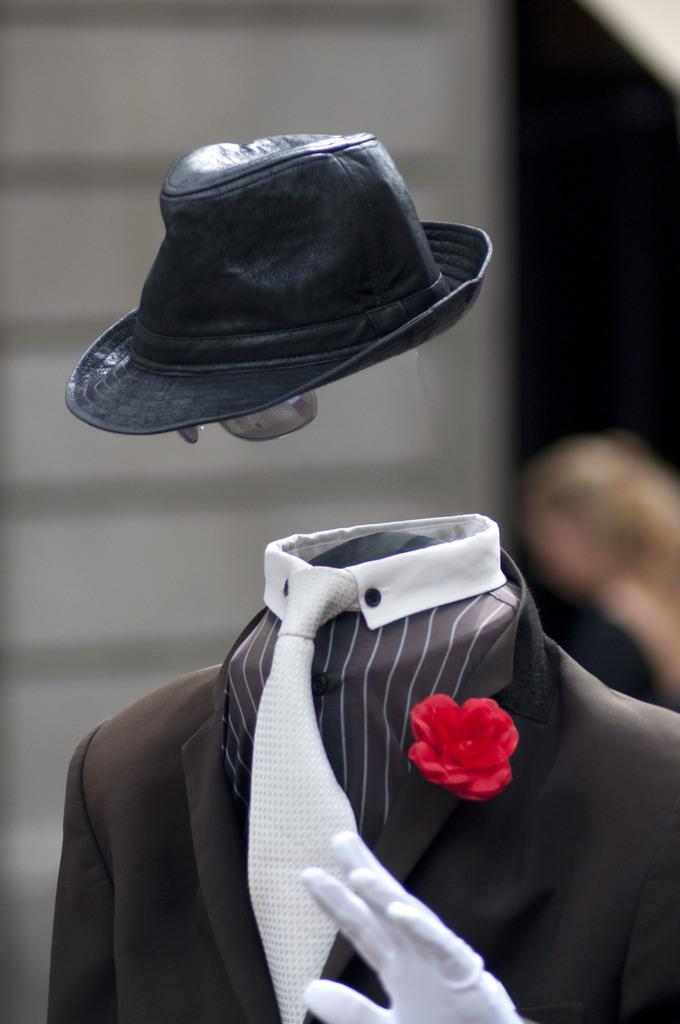What type of clothing is visible in the image? There is a suit in the image. What decorative element is on the suit? There is a flower on the suit. What type of headwear is present in the image? There is a hat at the top of the image. Can you describe the person behind the suit? There is a person behind the suit, but no specific details about the person are provided. How would you describe the background of the image? The background of the image is blurred. What type of linen is used to make the owl's bed in the image? There is no owl or bed present in the image, so it is not possible to answer that question. 